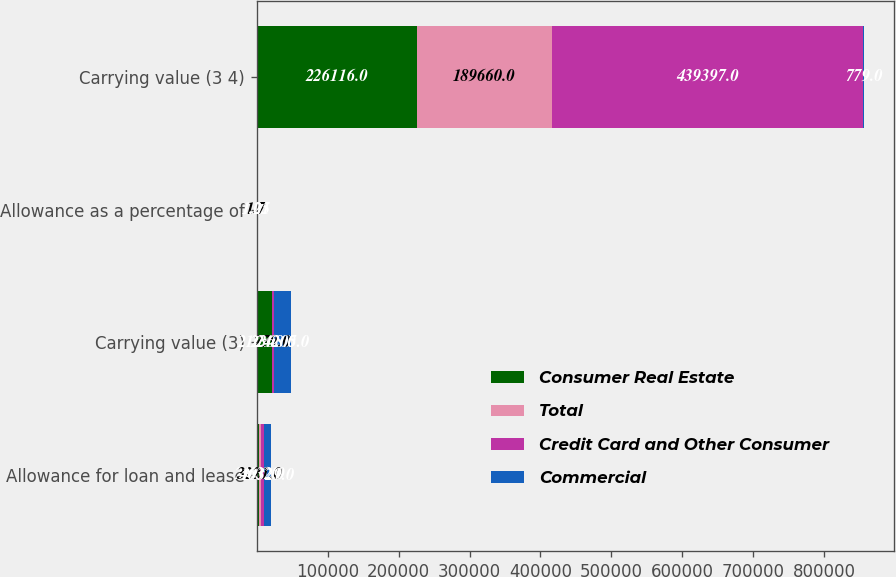Convert chart. <chart><loc_0><loc_0><loc_500><loc_500><stacked_bar_chart><ecel><fcel>Allowance for loan and lease<fcel>Carrying value (3)<fcel>Allowance as a percentage of<fcel>Carrying value (3 4)<nl><fcel>Consumer Real Estate<fcel>2476<fcel>21058<fcel>1.1<fcel>226116<nl><fcel>Total<fcel>3221<fcel>779<fcel>1.7<fcel>189660<nl><fcel>Credit Card and Other Consumer<fcel>4632<fcel>2368<fcel>1.05<fcel>439397<nl><fcel>Commercial<fcel>10329<fcel>24205<fcel>1.21<fcel>779<nl></chart> 